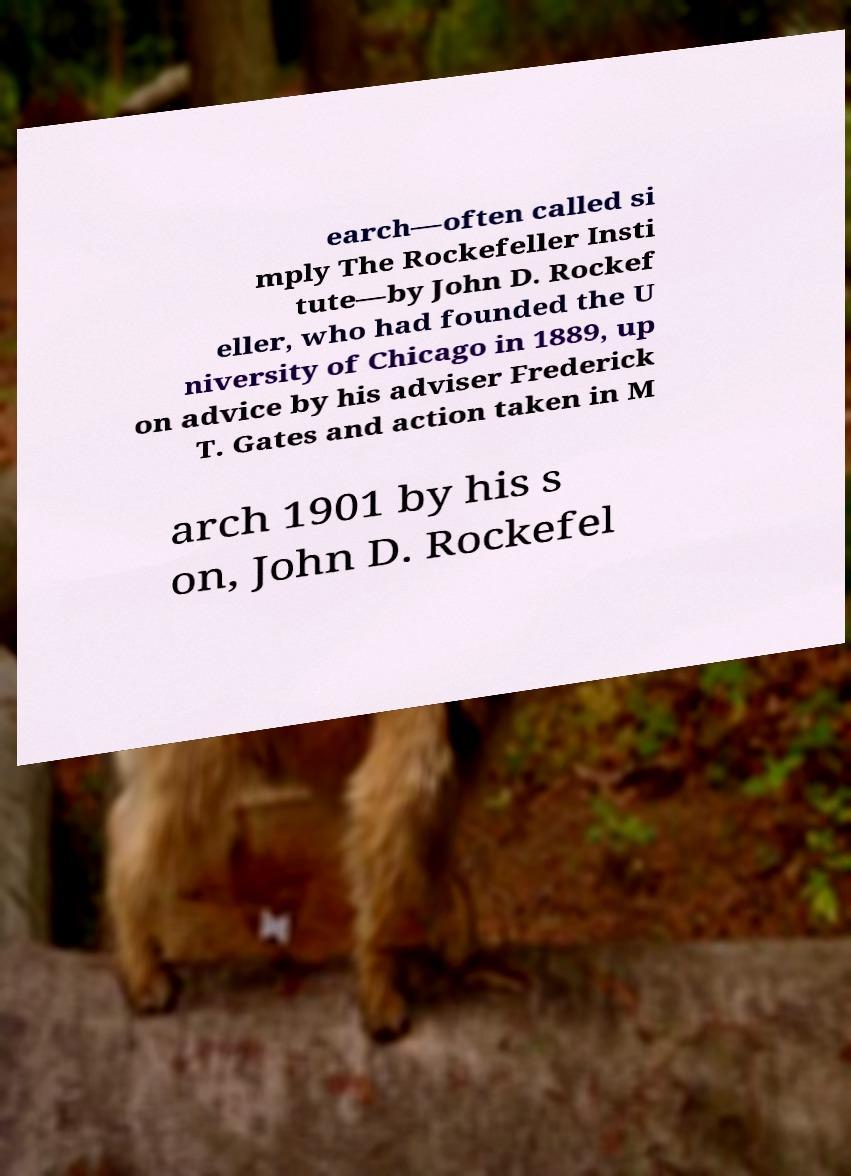Please identify and transcribe the text found in this image. earch—often called si mply The Rockefeller Insti tute—by John D. Rockef eller, who had founded the U niversity of Chicago in 1889, up on advice by his adviser Frederick T. Gates and action taken in M arch 1901 by his s on, John D. Rockefel 